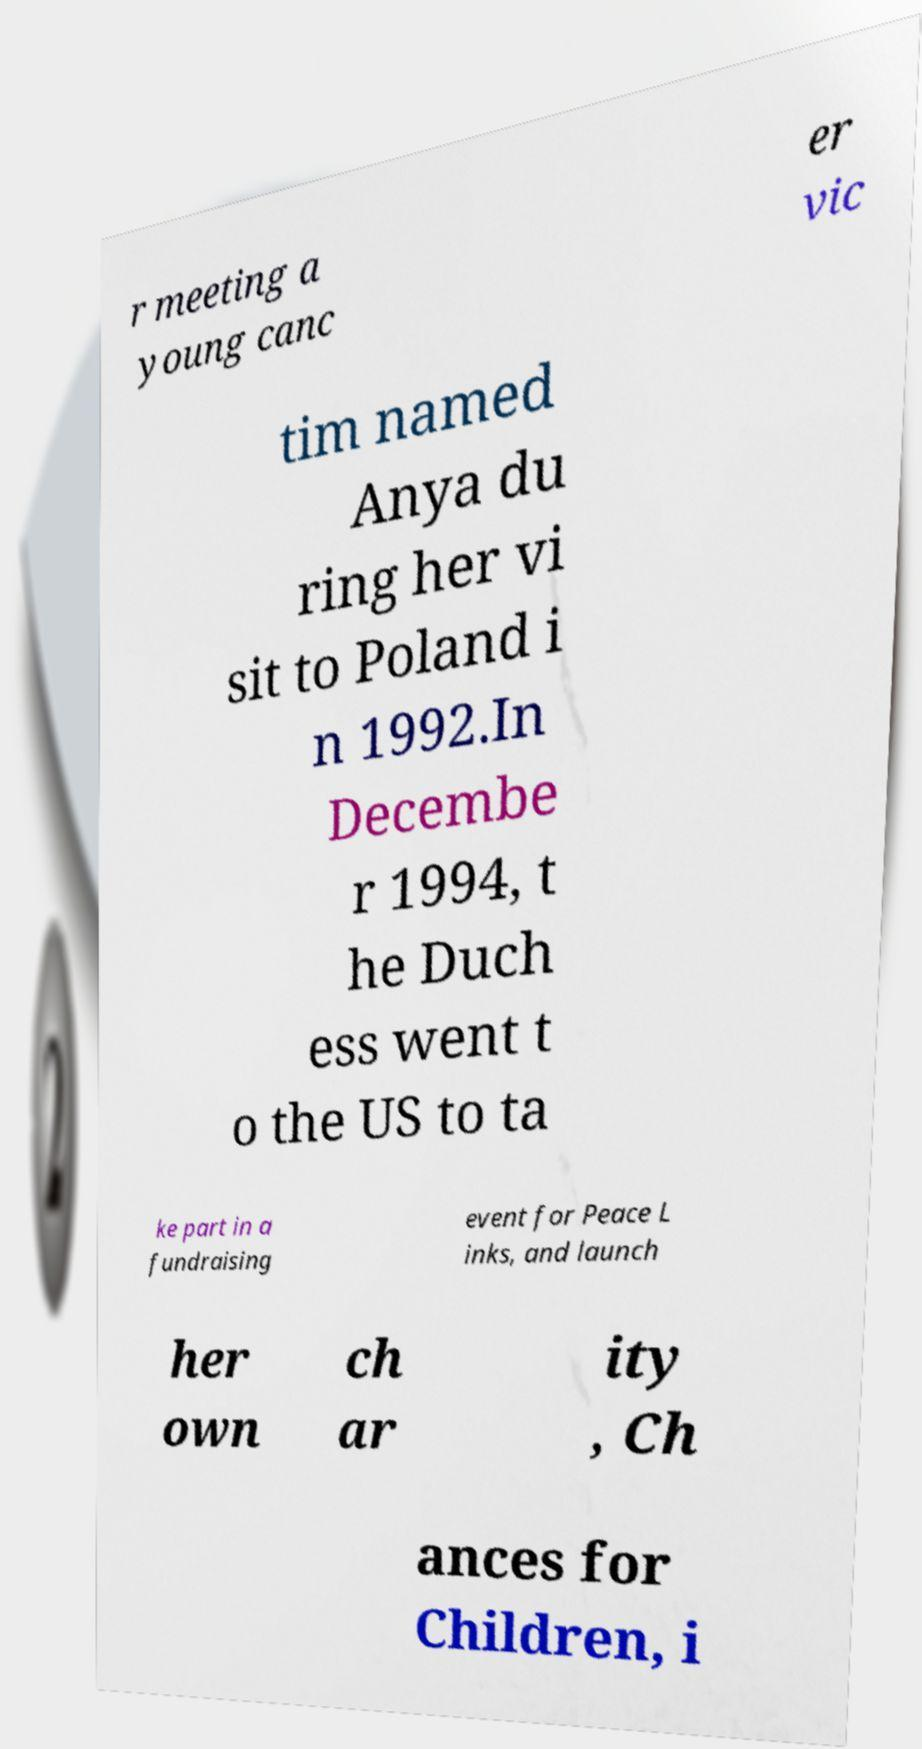Could you assist in decoding the text presented in this image and type it out clearly? r meeting a young canc er vic tim named Anya du ring her vi sit to Poland i n 1992.In Decembe r 1994, t he Duch ess went t o the US to ta ke part in a fundraising event for Peace L inks, and launch her own ch ar ity , Ch ances for Children, i 